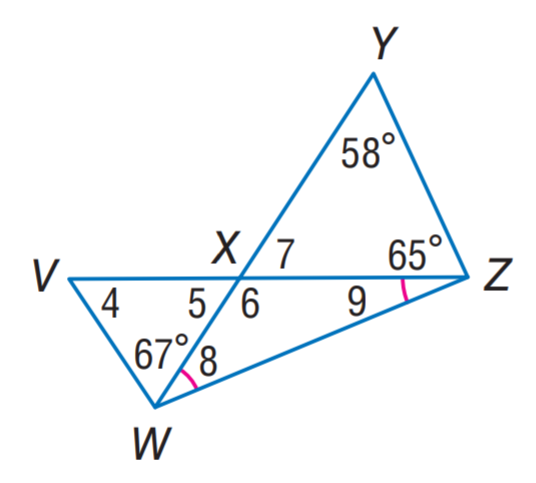Answer the mathemtical geometry problem and directly provide the correct option letter.
Question: Find m \angle 5.
Choices: A: 28.5 B: 56 C: 57 D: 123 C 